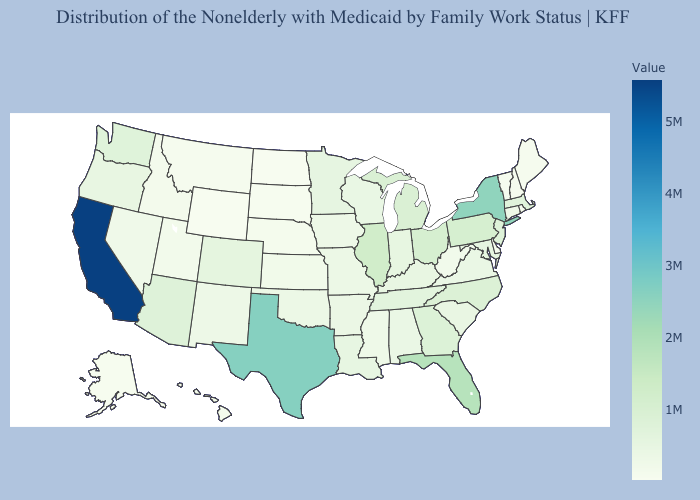Among the states that border Delaware , does New Jersey have the highest value?
Keep it brief. No. Which states hav the highest value in the West?
Short answer required. California. Which states have the lowest value in the USA?
Be succinct. North Dakota. 